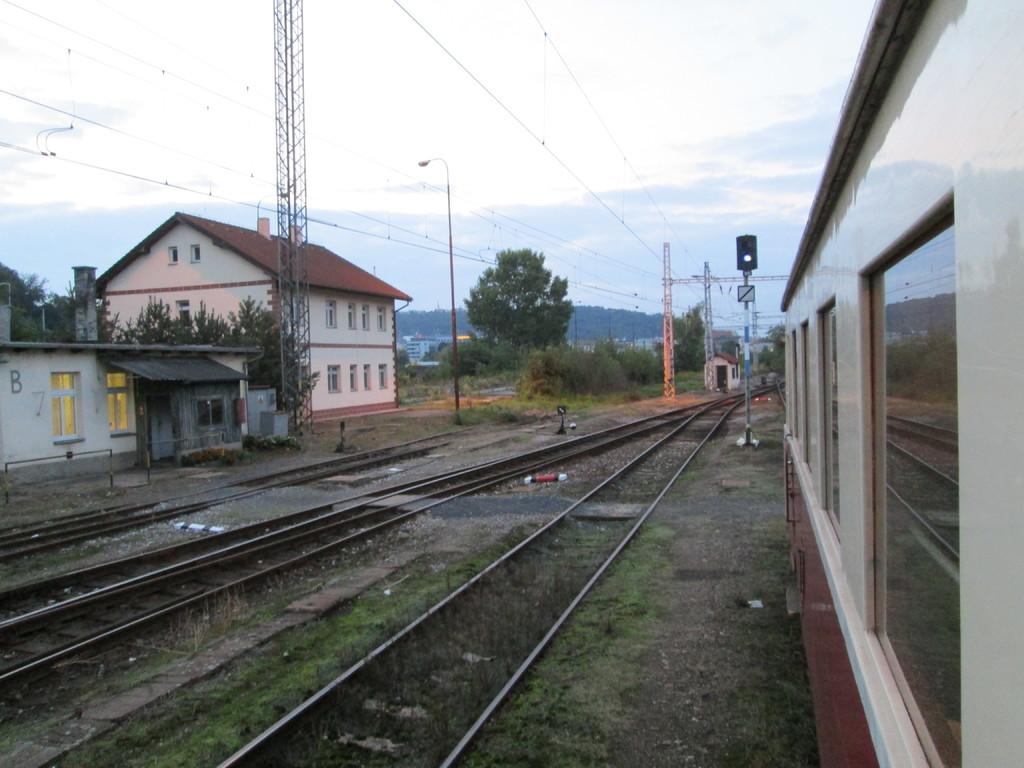What type of structures are located on the left side of the image? There are houses on the left side of the image. What mode of transportation can be seen on the right side of the image? There is a train on the right side of the image. Where is the train situated in the image? The train is on a railway track. What type of vegetation is in the middle of the image? There are trees in the middle of the image. What is visible at the top of the image? The sky is visible at the top of the image. What type of reaction is taking place in the image involving a volcano? There is no volcano present in the image, so no such reaction can be observed. How many balloons are floating in the sky in the image? There are no balloons visible in the image; only houses, a train, trees, and the sky are present. 